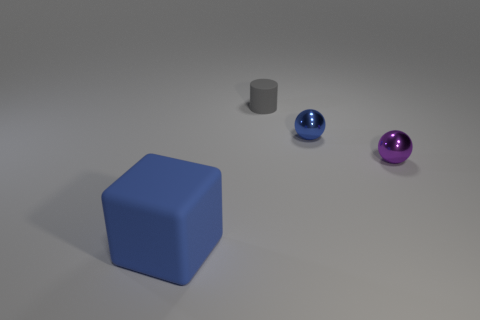What number of cyan objects are big rubber things or tiny cylinders?
Your response must be concise. 0. What number of small things are the same color as the large matte block?
Your answer should be compact. 1. Is the material of the big block the same as the gray thing?
Provide a succinct answer. Yes. There is a shiny ball that is behind the tiny purple object; how many small blue shiny objects are on the right side of it?
Make the answer very short. 0. Do the gray cylinder and the purple ball have the same size?
Make the answer very short. Yes. What number of tiny purple balls have the same material as the big object?
Your answer should be compact. 0. What is the size of the other metallic thing that is the same shape as the small blue shiny object?
Give a very brief answer. Small. Is the shape of the blue object right of the large blue object the same as  the large blue rubber thing?
Your answer should be compact. No. There is a shiny thing that is to the left of the thing to the right of the small blue ball; what shape is it?
Your answer should be compact. Sphere. Are there any other things that are the same shape as the large matte thing?
Your response must be concise. No. 